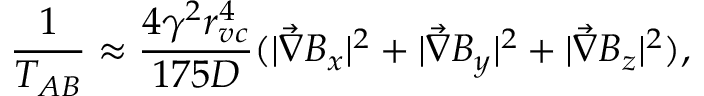<formula> <loc_0><loc_0><loc_500><loc_500>\frac { 1 } { T _ { A B } } \approx \frac { 4 \gamma ^ { 2 } r _ { v c } ^ { 4 } } { 1 7 5 D } ( | \vec { \nabla } B _ { x } | ^ { 2 } + | \vec { \nabla } B _ { y } | ^ { 2 } + | \vec { \nabla } B _ { z } | ^ { 2 } ) ,</formula> 